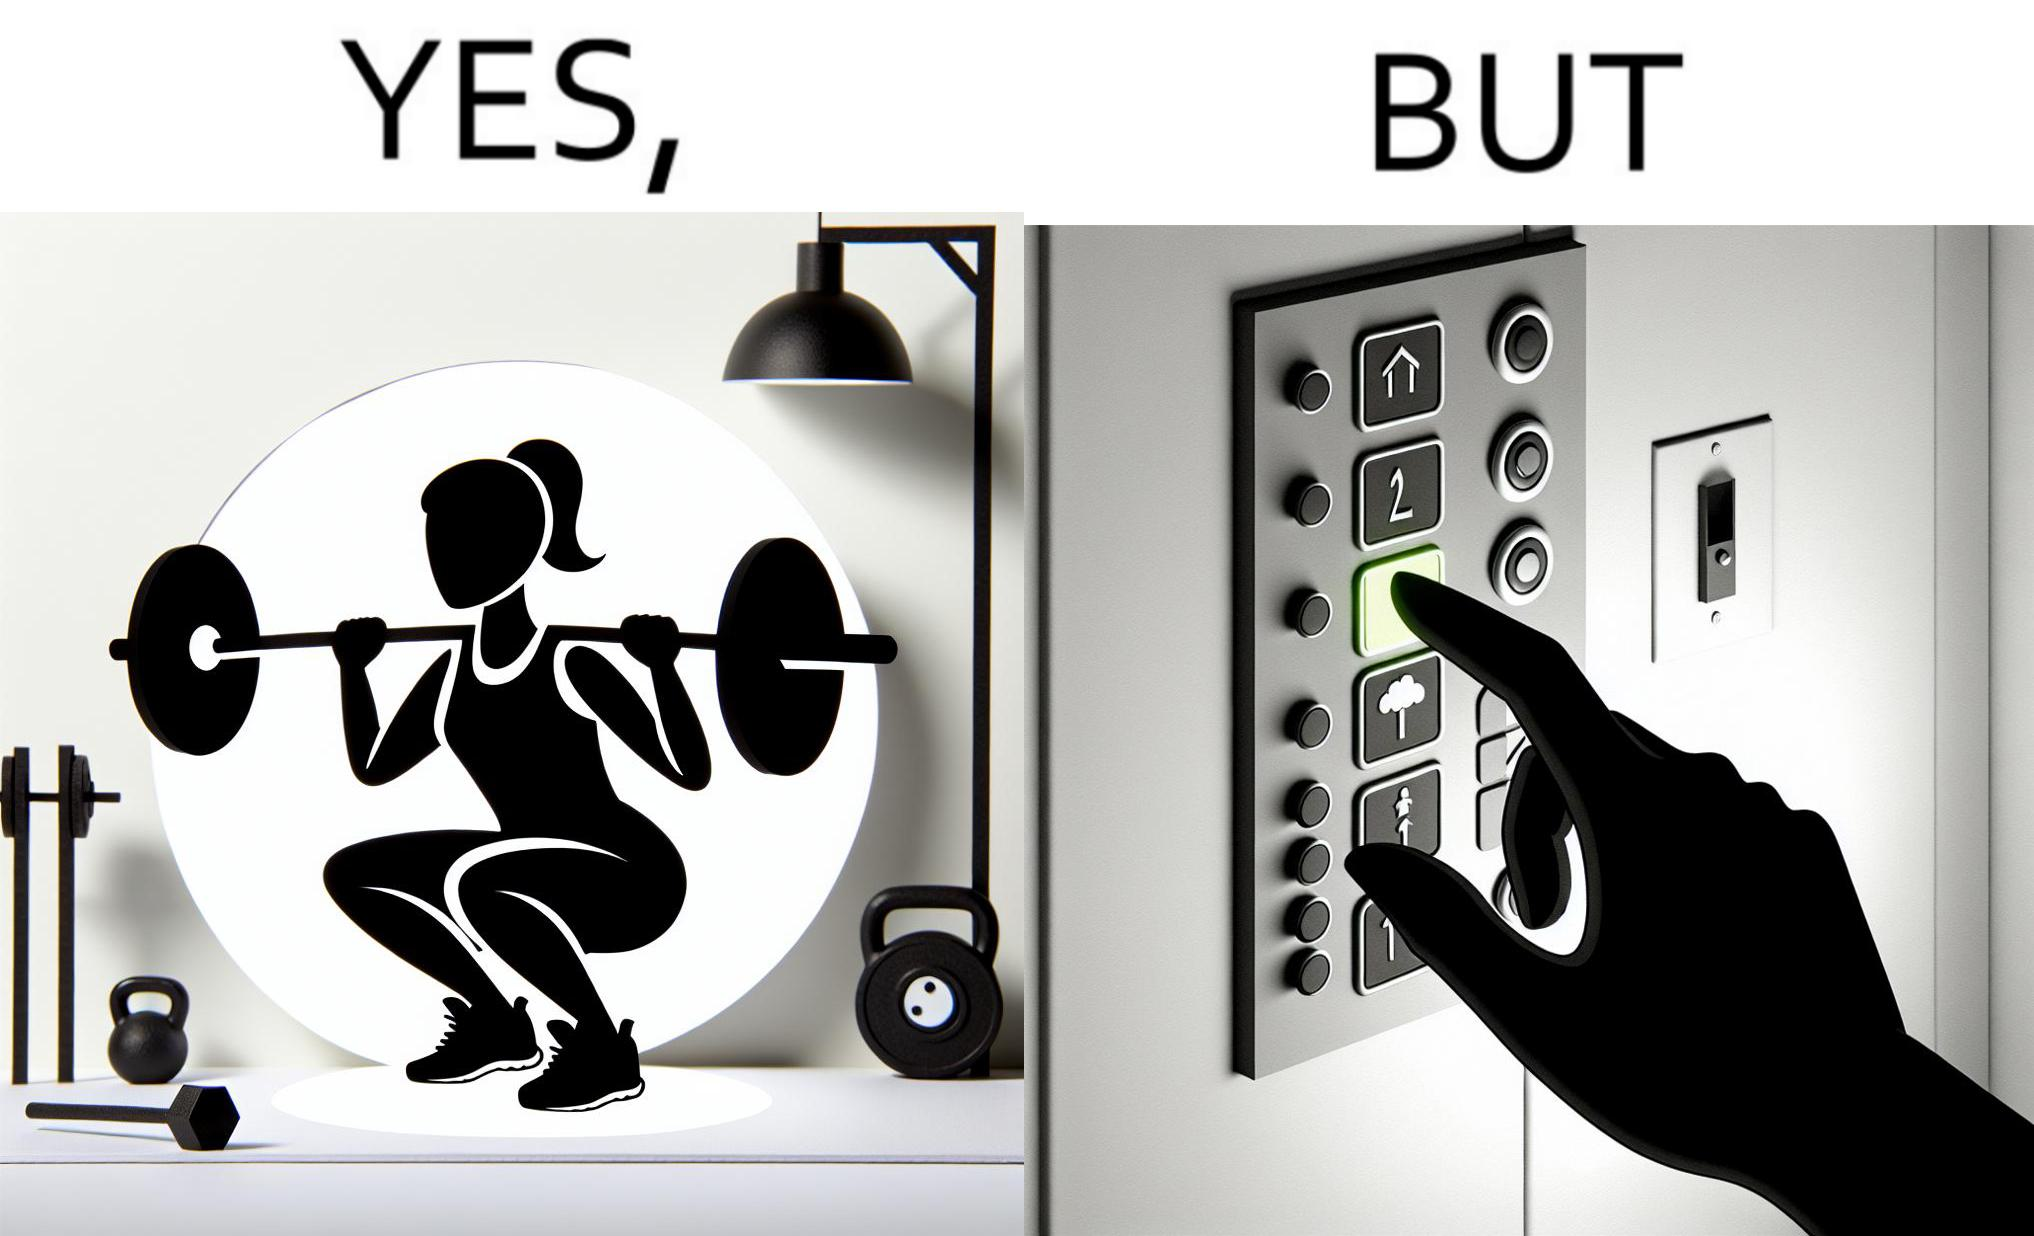Describe the contrast between the left and right parts of this image. In the left part of the image: The image shows a women exercising with a bar bell in a gym. She is wearing a sport outfit. She is crouching down on one leg doing a single leg squat with a bar bell. In the right part of the image: The image shows the control panel inside of an elevator. The indicator for the first floor is green which means the button for the first floor was pressed. A hand is about to press the button for the second floor. 